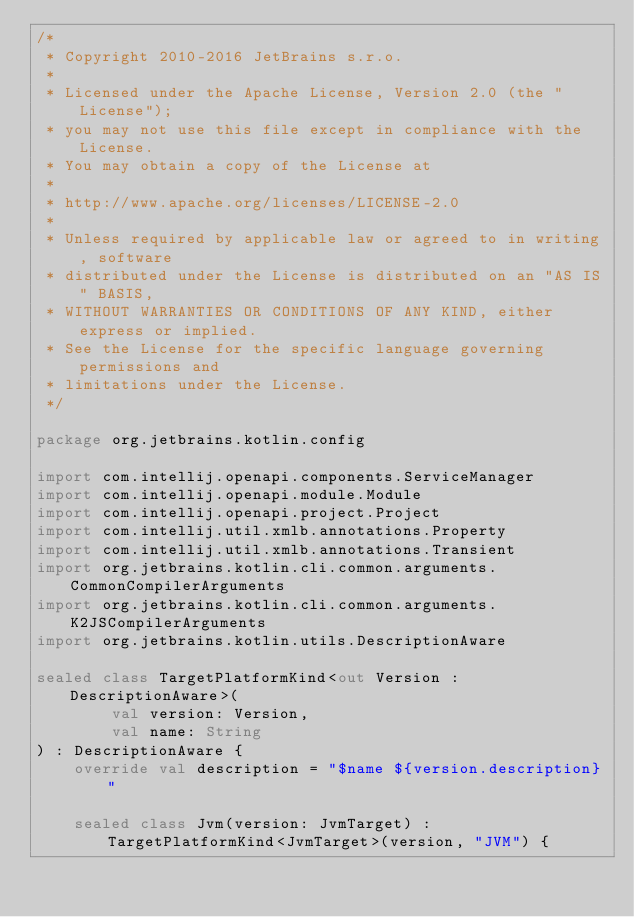<code> <loc_0><loc_0><loc_500><loc_500><_Kotlin_>/*
 * Copyright 2010-2016 JetBrains s.r.o.
 *
 * Licensed under the Apache License, Version 2.0 (the "License");
 * you may not use this file except in compliance with the License.
 * You may obtain a copy of the License at
 *
 * http://www.apache.org/licenses/LICENSE-2.0
 *
 * Unless required by applicable law or agreed to in writing, software
 * distributed under the License is distributed on an "AS IS" BASIS,
 * WITHOUT WARRANTIES OR CONDITIONS OF ANY KIND, either express or implied.
 * See the License for the specific language governing permissions and
 * limitations under the License.
 */

package org.jetbrains.kotlin.config

import com.intellij.openapi.components.ServiceManager
import com.intellij.openapi.module.Module
import com.intellij.openapi.project.Project
import com.intellij.util.xmlb.annotations.Property
import com.intellij.util.xmlb.annotations.Transient
import org.jetbrains.kotlin.cli.common.arguments.CommonCompilerArguments
import org.jetbrains.kotlin.cli.common.arguments.K2JSCompilerArguments
import org.jetbrains.kotlin.utils.DescriptionAware

sealed class TargetPlatformKind<out Version : DescriptionAware>(
        val version: Version,
        val name: String
) : DescriptionAware {
    override val description = "$name ${version.description}"

    sealed class Jvm(version: JvmTarget) : TargetPlatformKind<JvmTarget>(version, "JVM") {</code> 